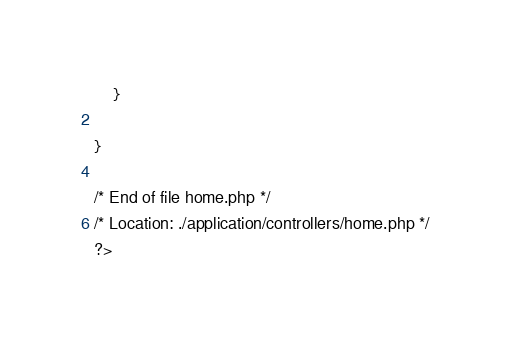Convert code to text. <code><loc_0><loc_0><loc_500><loc_500><_PHP_>	}

}

/* End of file home.php */
/* Location: ./application/controllers/home.php */
?></code> 